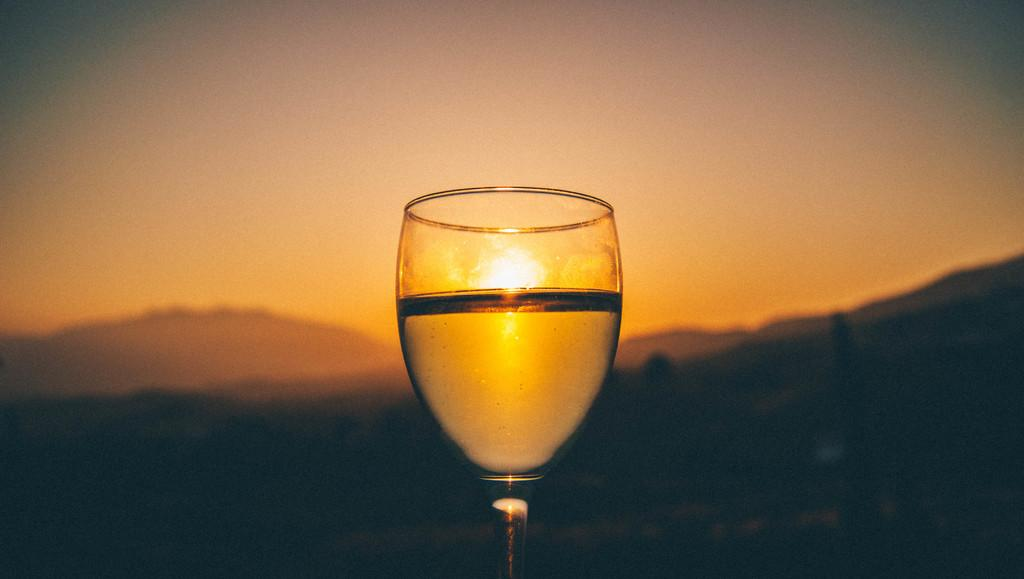What object is present in the image? There is a glass in the image. What can be seen in the background of the image? There is a sunrise in the background of the image. How would you describe the lighting in the bottom part of the image? The bottom part of the image is dark. What type of request is being made in the image? There is no request present in the image; it only features a glass and a sunrise in the background. 